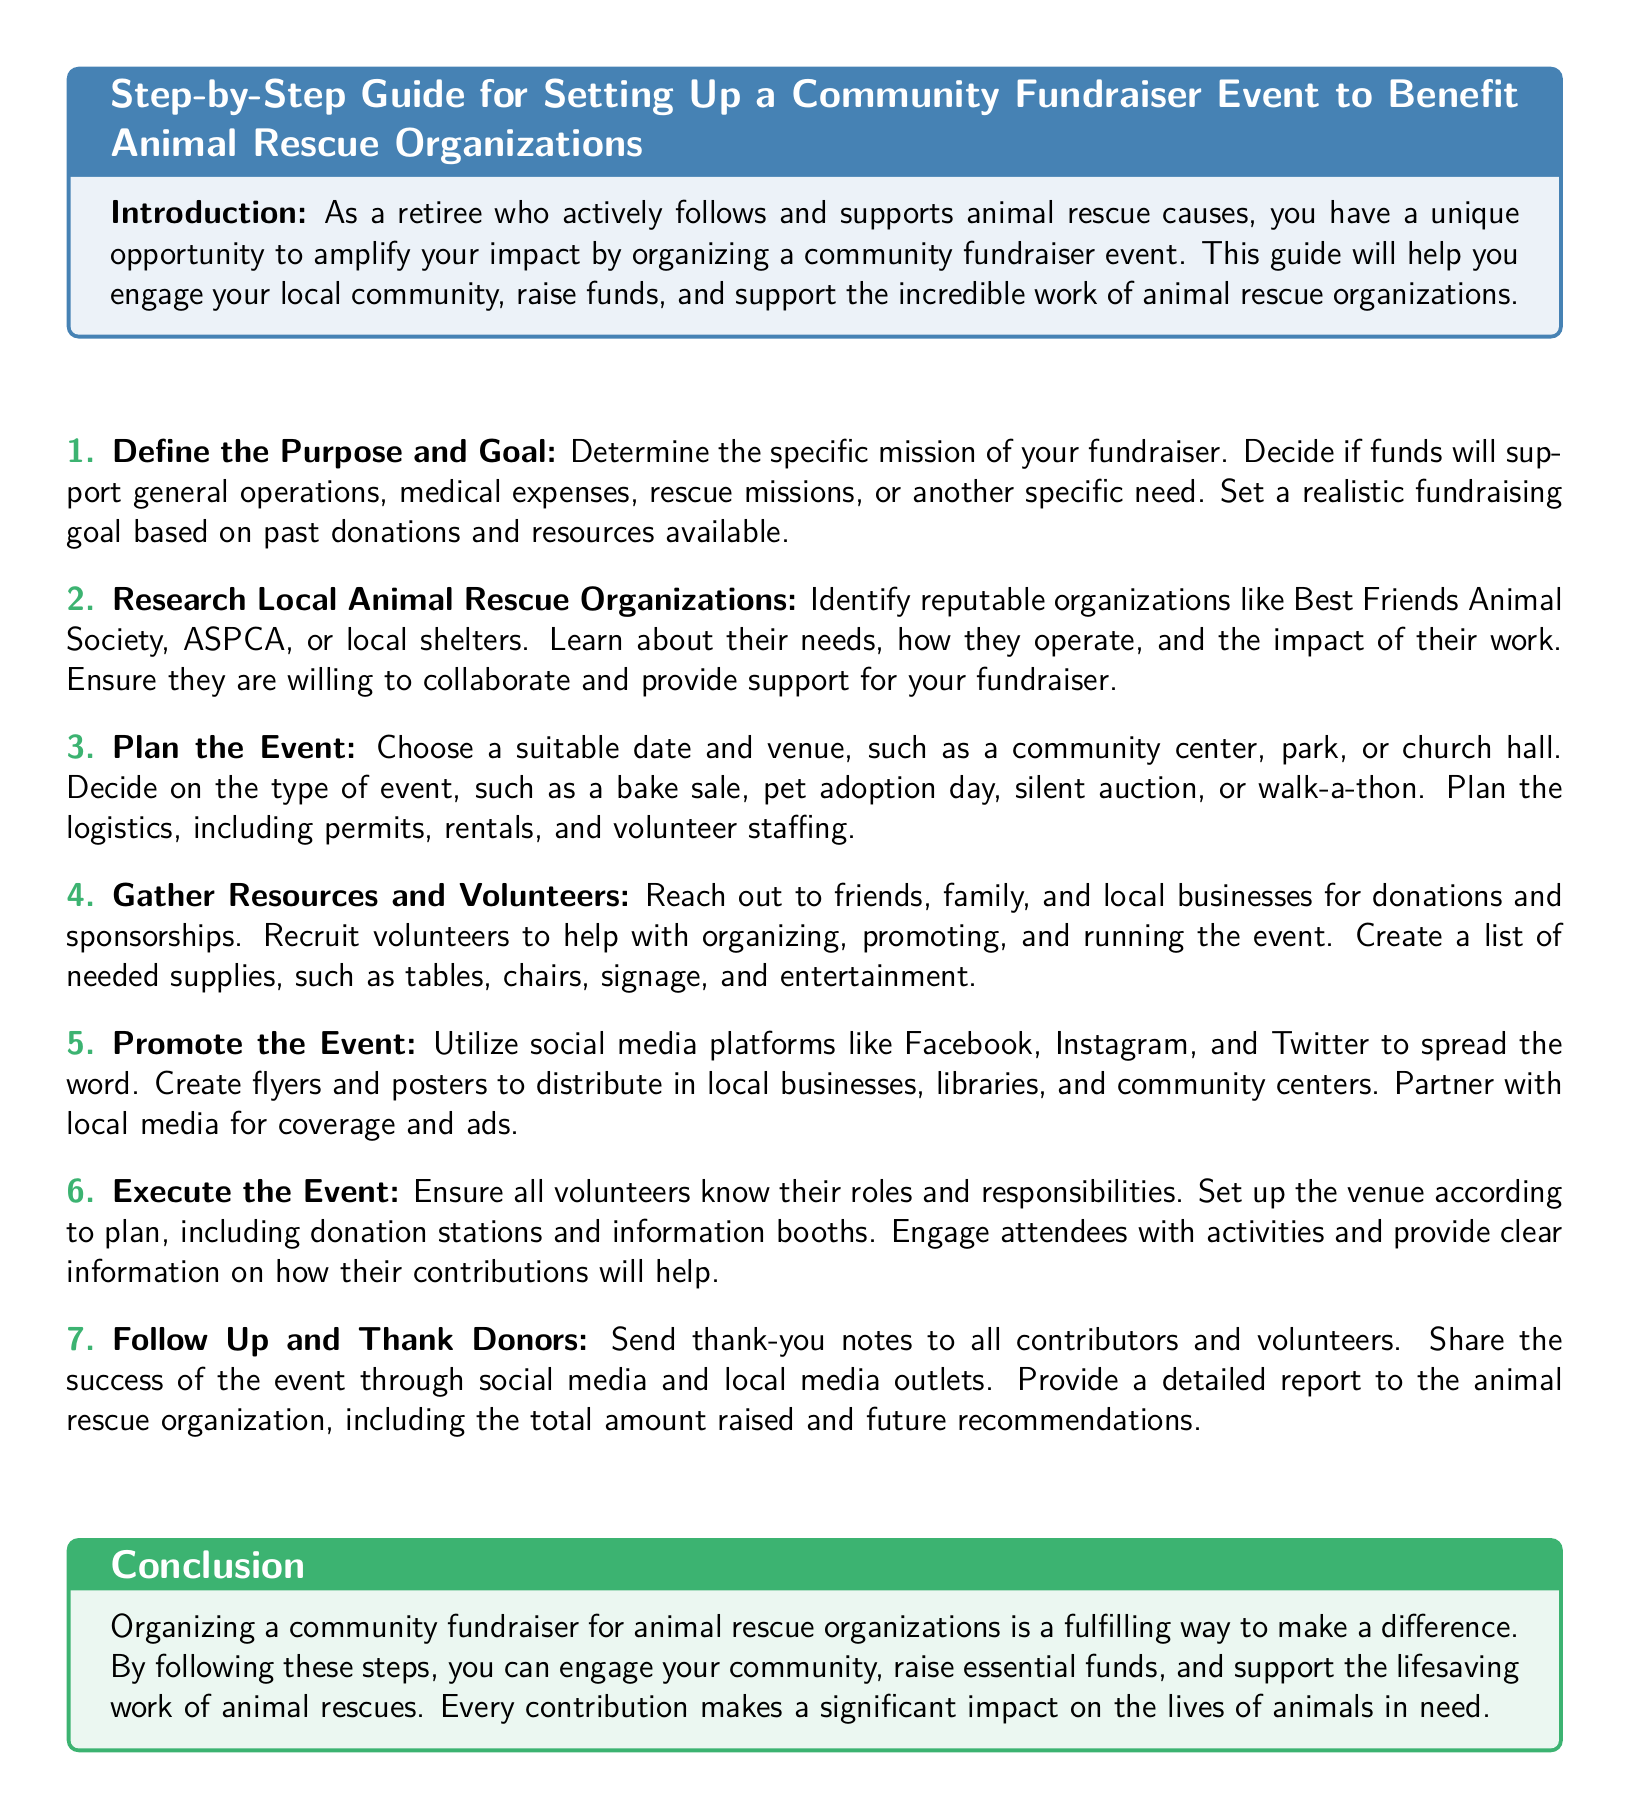What is the main purpose of the document? The document serves as a guide for organizing a community fundraiser event to support animal rescue organizations.
Answer: Community fundraiser event What are the first steps outlined in the document? The document lists defining the purpose and goal as the first step in organizing a fundraiser.
Answer: Define the Purpose and Goal Which organization is mentioned as a reputable animal rescue organization? The document mentions Best Friends Animal Society as a reputable organization.
Answer: Best Friends Animal Society What is a suggested event type for fundraising? The document suggests several types of events, one of which is a bake sale.
Answer: Bake sale What should be done after the event? The document emphasizes sending thank-you notes to donors and volunteers after the event.
Answer: Thank-you notes How many major steps are listed in the fundraising process? The document outlines a total of seven major steps to follow when organizing a fundraiser.
Answer: Seven Which color is used for the title headings? The document indicates that the titles are in pet blue color.
Answer: Pet blue What should be created for promoting the event? The document recommends creating flyers and posters for event promotion.
Answer: Flyers and posters Who should be thanked after the event? According to the document, both contributors and volunteers should be thanked after the event.
Answer: Contributors and volunteers 